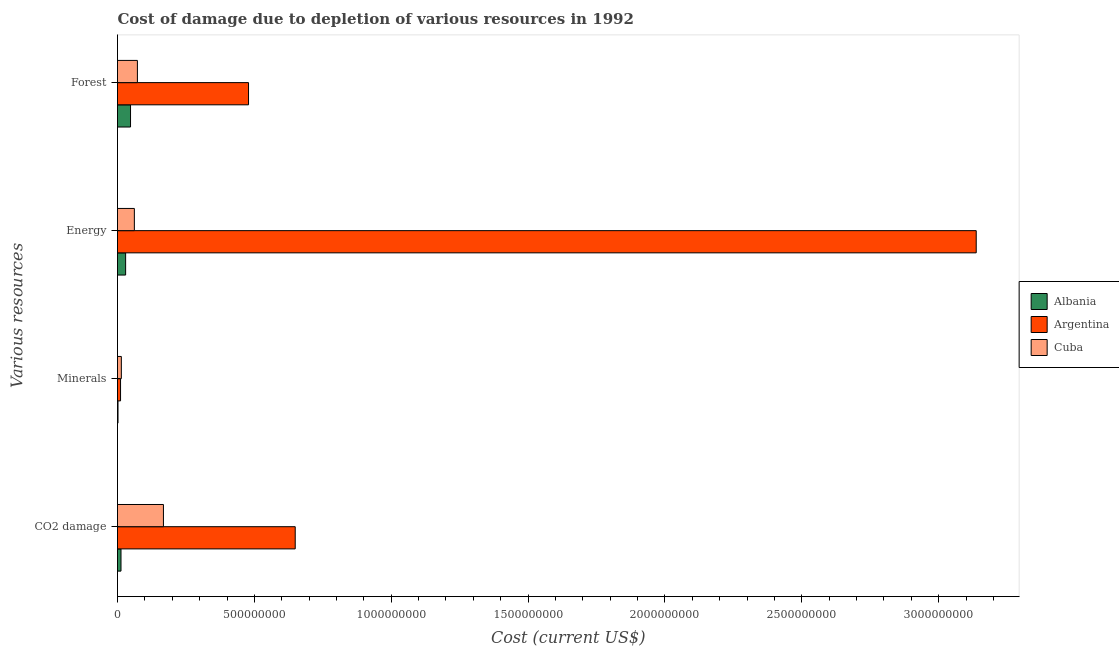How many bars are there on the 4th tick from the top?
Your response must be concise. 3. What is the label of the 1st group of bars from the top?
Make the answer very short. Forest. What is the cost of damage due to depletion of energy in Argentina?
Provide a succinct answer. 3.14e+09. Across all countries, what is the maximum cost of damage due to depletion of forests?
Keep it short and to the point. 4.79e+08. Across all countries, what is the minimum cost of damage due to depletion of minerals?
Your answer should be compact. 1.85e+06. In which country was the cost of damage due to depletion of coal maximum?
Give a very brief answer. Argentina. In which country was the cost of damage due to depletion of coal minimum?
Your answer should be compact. Albania. What is the total cost of damage due to depletion of forests in the graph?
Ensure brevity in your answer.  5.99e+08. What is the difference between the cost of damage due to depletion of energy in Albania and that in Argentina?
Your response must be concise. -3.11e+09. What is the difference between the cost of damage due to depletion of coal in Cuba and the cost of damage due to depletion of energy in Argentina?
Make the answer very short. -2.97e+09. What is the average cost of damage due to depletion of coal per country?
Offer a terse response. 2.77e+08. What is the difference between the cost of damage due to depletion of minerals and cost of damage due to depletion of coal in Albania?
Provide a short and direct response. -1.09e+07. In how many countries, is the cost of damage due to depletion of minerals greater than 1200000000 US$?
Your answer should be very brief. 0. What is the ratio of the cost of damage due to depletion of minerals in Albania to that in Cuba?
Keep it short and to the point. 0.13. What is the difference between the highest and the second highest cost of damage due to depletion of energy?
Offer a terse response. 3.08e+09. What is the difference between the highest and the lowest cost of damage due to depletion of forests?
Offer a terse response. 4.31e+08. What does the 2nd bar from the bottom in Energy represents?
Make the answer very short. Argentina. How many bars are there?
Offer a very short reply. 12. Are all the bars in the graph horizontal?
Keep it short and to the point. Yes. What is the difference between two consecutive major ticks on the X-axis?
Make the answer very short. 5.00e+08. How many legend labels are there?
Give a very brief answer. 3. What is the title of the graph?
Your response must be concise. Cost of damage due to depletion of various resources in 1992 . What is the label or title of the X-axis?
Give a very brief answer. Cost (current US$). What is the label or title of the Y-axis?
Offer a very short reply. Various resources. What is the Cost (current US$) of Albania in CO2 damage?
Ensure brevity in your answer.  1.28e+07. What is the Cost (current US$) of Argentina in CO2 damage?
Offer a very short reply. 6.49e+08. What is the Cost (current US$) in Cuba in CO2 damage?
Ensure brevity in your answer.  1.68e+08. What is the Cost (current US$) in Albania in Minerals?
Make the answer very short. 1.85e+06. What is the Cost (current US$) in Argentina in Minerals?
Keep it short and to the point. 1.11e+07. What is the Cost (current US$) in Cuba in Minerals?
Ensure brevity in your answer.  1.40e+07. What is the Cost (current US$) of Albania in Energy?
Provide a short and direct response. 2.97e+07. What is the Cost (current US$) of Argentina in Energy?
Keep it short and to the point. 3.14e+09. What is the Cost (current US$) of Cuba in Energy?
Provide a short and direct response. 6.16e+07. What is the Cost (current US$) in Albania in Forest?
Offer a very short reply. 4.76e+07. What is the Cost (current US$) in Argentina in Forest?
Keep it short and to the point. 4.79e+08. What is the Cost (current US$) in Cuba in Forest?
Your answer should be compact. 7.27e+07. Across all Various resources, what is the maximum Cost (current US$) of Albania?
Offer a terse response. 4.76e+07. Across all Various resources, what is the maximum Cost (current US$) of Argentina?
Provide a short and direct response. 3.14e+09. Across all Various resources, what is the maximum Cost (current US$) in Cuba?
Make the answer very short. 1.68e+08. Across all Various resources, what is the minimum Cost (current US$) of Albania?
Your response must be concise. 1.85e+06. Across all Various resources, what is the minimum Cost (current US$) of Argentina?
Offer a terse response. 1.11e+07. Across all Various resources, what is the minimum Cost (current US$) of Cuba?
Offer a very short reply. 1.40e+07. What is the total Cost (current US$) in Albania in the graph?
Provide a short and direct response. 9.18e+07. What is the total Cost (current US$) in Argentina in the graph?
Give a very brief answer. 4.28e+09. What is the total Cost (current US$) of Cuba in the graph?
Make the answer very short. 3.16e+08. What is the difference between the Cost (current US$) in Albania in CO2 damage and that in Minerals?
Keep it short and to the point. 1.09e+07. What is the difference between the Cost (current US$) of Argentina in CO2 damage and that in Minerals?
Offer a terse response. 6.38e+08. What is the difference between the Cost (current US$) of Cuba in CO2 damage and that in Minerals?
Offer a terse response. 1.54e+08. What is the difference between the Cost (current US$) in Albania in CO2 damage and that in Energy?
Your answer should be compact. -1.69e+07. What is the difference between the Cost (current US$) of Argentina in CO2 damage and that in Energy?
Your answer should be compact. -2.49e+09. What is the difference between the Cost (current US$) of Cuba in CO2 damage and that in Energy?
Keep it short and to the point. 1.06e+08. What is the difference between the Cost (current US$) of Albania in CO2 damage and that in Forest?
Offer a terse response. -3.48e+07. What is the difference between the Cost (current US$) in Argentina in CO2 damage and that in Forest?
Provide a short and direct response. 1.71e+08. What is the difference between the Cost (current US$) of Cuba in CO2 damage and that in Forest?
Make the answer very short. 9.51e+07. What is the difference between the Cost (current US$) in Albania in Minerals and that in Energy?
Give a very brief answer. -2.78e+07. What is the difference between the Cost (current US$) in Argentina in Minerals and that in Energy?
Your answer should be very brief. -3.13e+09. What is the difference between the Cost (current US$) of Cuba in Minerals and that in Energy?
Offer a very short reply. -4.76e+07. What is the difference between the Cost (current US$) in Albania in Minerals and that in Forest?
Make the answer very short. -4.57e+07. What is the difference between the Cost (current US$) of Argentina in Minerals and that in Forest?
Provide a succinct answer. -4.68e+08. What is the difference between the Cost (current US$) of Cuba in Minerals and that in Forest?
Make the answer very short. -5.87e+07. What is the difference between the Cost (current US$) in Albania in Energy and that in Forest?
Provide a short and direct response. -1.79e+07. What is the difference between the Cost (current US$) in Argentina in Energy and that in Forest?
Give a very brief answer. 2.66e+09. What is the difference between the Cost (current US$) of Cuba in Energy and that in Forest?
Your answer should be compact. -1.11e+07. What is the difference between the Cost (current US$) of Albania in CO2 damage and the Cost (current US$) of Argentina in Minerals?
Make the answer very short. 1.66e+06. What is the difference between the Cost (current US$) of Albania in CO2 damage and the Cost (current US$) of Cuba in Minerals?
Make the answer very short. -1.26e+06. What is the difference between the Cost (current US$) of Argentina in CO2 damage and the Cost (current US$) of Cuba in Minerals?
Keep it short and to the point. 6.35e+08. What is the difference between the Cost (current US$) in Albania in CO2 damage and the Cost (current US$) in Argentina in Energy?
Ensure brevity in your answer.  -3.12e+09. What is the difference between the Cost (current US$) in Albania in CO2 damage and the Cost (current US$) in Cuba in Energy?
Give a very brief answer. -4.88e+07. What is the difference between the Cost (current US$) in Argentina in CO2 damage and the Cost (current US$) in Cuba in Energy?
Offer a very short reply. 5.88e+08. What is the difference between the Cost (current US$) of Albania in CO2 damage and the Cost (current US$) of Argentina in Forest?
Your response must be concise. -4.66e+08. What is the difference between the Cost (current US$) in Albania in CO2 damage and the Cost (current US$) in Cuba in Forest?
Your answer should be very brief. -6.00e+07. What is the difference between the Cost (current US$) of Argentina in CO2 damage and the Cost (current US$) of Cuba in Forest?
Provide a succinct answer. 5.76e+08. What is the difference between the Cost (current US$) of Albania in Minerals and the Cost (current US$) of Argentina in Energy?
Ensure brevity in your answer.  -3.14e+09. What is the difference between the Cost (current US$) of Albania in Minerals and the Cost (current US$) of Cuba in Energy?
Offer a terse response. -5.97e+07. What is the difference between the Cost (current US$) in Argentina in Minerals and the Cost (current US$) in Cuba in Energy?
Your response must be concise. -5.05e+07. What is the difference between the Cost (current US$) of Albania in Minerals and the Cost (current US$) of Argentina in Forest?
Offer a terse response. -4.77e+08. What is the difference between the Cost (current US$) of Albania in Minerals and the Cost (current US$) of Cuba in Forest?
Provide a short and direct response. -7.09e+07. What is the difference between the Cost (current US$) of Argentina in Minerals and the Cost (current US$) of Cuba in Forest?
Give a very brief answer. -6.16e+07. What is the difference between the Cost (current US$) of Albania in Energy and the Cost (current US$) of Argentina in Forest?
Make the answer very short. -4.49e+08. What is the difference between the Cost (current US$) in Albania in Energy and the Cost (current US$) in Cuba in Forest?
Make the answer very short. -4.31e+07. What is the difference between the Cost (current US$) in Argentina in Energy and the Cost (current US$) in Cuba in Forest?
Offer a terse response. 3.06e+09. What is the average Cost (current US$) in Albania per Various resources?
Offer a terse response. 2.30e+07. What is the average Cost (current US$) in Argentina per Various resources?
Provide a succinct answer. 1.07e+09. What is the average Cost (current US$) in Cuba per Various resources?
Provide a short and direct response. 7.90e+07. What is the difference between the Cost (current US$) of Albania and Cost (current US$) of Argentina in CO2 damage?
Ensure brevity in your answer.  -6.36e+08. What is the difference between the Cost (current US$) in Albania and Cost (current US$) in Cuba in CO2 damage?
Provide a short and direct response. -1.55e+08. What is the difference between the Cost (current US$) of Argentina and Cost (current US$) of Cuba in CO2 damage?
Your answer should be compact. 4.81e+08. What is the difference between the Cost (current US$) in Albania and Cost (current US$) in Argentina in Minerals?
Offer a terse response. -9.26e+06. What is the difference between the Cost (current US$) of Albania and Cost (current US$) of Cuba in Minerals?
Provide a succinct answer. -1.22e+07. What is the difference between the Cost (current US$) of Argentina and Cost (current US$) of Cuba in Minerals?
Provide a succinct answer. -2.92e+06. What is the difference between the Cost (current US$) of Albania and Cost (current US$) of Argentina in Energy?
Give a very brief answer. -3.11e+09. What is the difference between the Cost (current US$) of Albania and Cost (current US$) of Cuba in Energy?
Give a very brief answer. -3.19e+07. What is the difference between the Cost (current US$) of Argentina and Cost (current US$) of Cuba in Energy?
Keep it short and to the point. 3.08e+09. What is the difference between the Cost (current US$) in Albania and Cost (current US$) in Argentina in Forest?
Make the answer very short. -4.31e+08. What is the difference between the Cost (current US$) in Albania and Cost (current US$) in Cuba in Forest?
Provide a succinct answer. -2.51e+07. What is the difference between the Cost (current US$) of Argentina and Cost (current US$) of Cuba in Forest?
Offer a terse response. 4.06e+08. What is the ratio of the Cost (current US$) in Albania in CO2 damage to that in Minerals?
Your response must be concise. 6.91. What is the ratio of the Cost (current US$) of Argentina in CO2 damage to that in Minerals?
Your answer should be compact. 58.46. What is the ratio of the Cost (current US$) in Cuba in CO2 damage to that in Minerals?
Provide a succinct answer. 11.96. What is the ratio of the Cost (current US$) in Albania in CO2 damage to that in Energy?
Offer a terse response. 0.43. What is the ratio of the Cost (current US$) of Argentina in CO2 damage to that in Energy?
Make the answer very short. 0.21. What is the ratio of the Cost (current US$) in Cuba in CO2 damage to that in Energy?
Your answer should be compact. 2.72. What is the ratio of the Cost (current US$) in Albania in CO2 damage to that in Forest?
Your answer should be very brief. 0.27. What is the ratio of the Cost (current US$) in Argentina in CO2 damage to that in Forest?
Your response must be concise. 1.36. What is the ratio of the Cost (current US$) of Cuba in CO2 damage to that in Forest?
Give a very brief answer. 2.31. What is the ratio of the Cost (current US$) of Albania in Minerals to that in Energy?
Make the answer very short. 0.06. What is the ratio of the Cost (current US$) of Argentina in Minerals to that in Energy?
Ensure brevity in your answer.  0. What is the ratio of the Cost (current US$) in Cuba in Minerals to that in Energy?
Your answer should be very brief. 0.23. What is the ratio of the Cost (current US$) in Albania in Minerals to that in Forest?
Ensure brevity in your answer.  0.04. What is the ratio of the Cost (current US$) in Argentina in Minerals to that in Forest?
Your answer should be very brief. 0.02. What is the ratio of the Cost (current US$) in Cuba in Minerals to that in Forest?
Keep it short and to the point. 0.19. What is the ratio of the Cost (current US$) in Albania in Energy to that in Forest?
Provide a succinct answer. 0.62. What is the ratio of the Cost (current US$) of Argentina in Energy to that in Forest?
Your answer should be compact. 6.55. What is the ratio of the Cost (current US$) in Cuba in Energy to that in Forest?
Provide a succinct answer. 0.85. What is the difference between the highest and the second highest Cost (current US$) in Albania?
Keep it short and to the point. 1.79e+07. What is the difference between the highest and the second highest Cost (current US$) in Argentina?
Provide a short and direct response. 2.49e+09. What is the difference between the highest and the second highest Cost (current US$) of Cuba?
Provide a short and direct response. 9.51e+07. What is the difference between the highest and the lowest Cost (current US$) of Albania?
Give a very brief answer. 4.57e+07. What is the difference between the highest and the lowest Cost (current US$) in Argentina?
Offer a terse response. 3.13e+09. What is the difference between the highest and the lowest Cost (current US$) of Cuba?
Keep it short and to the point. 1.54e+08. 